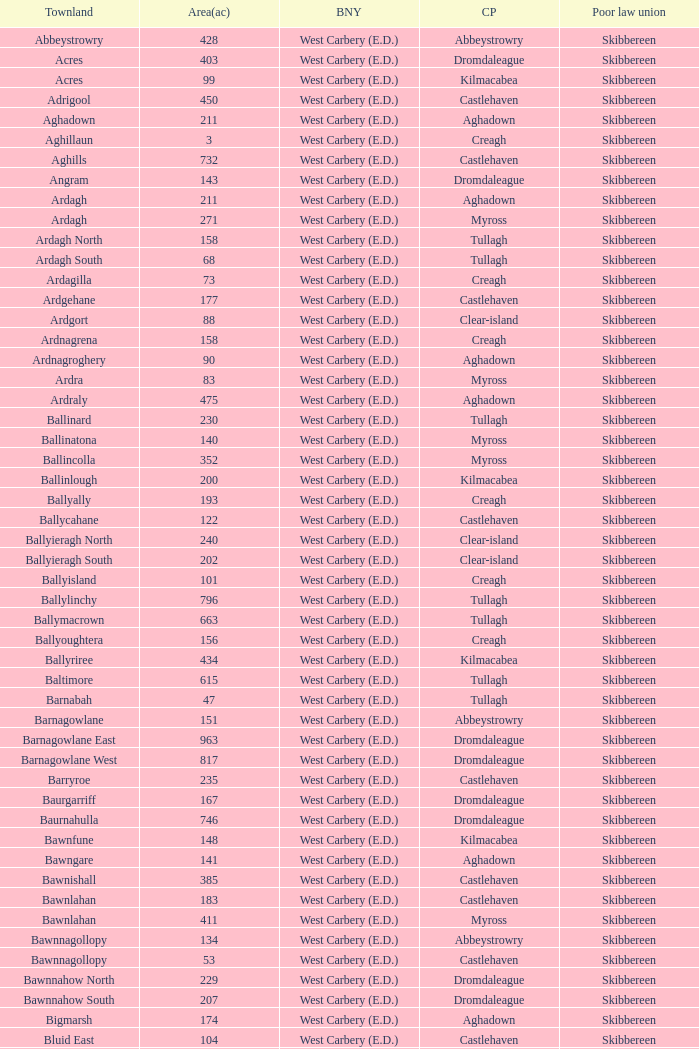What are the Poor Law Unions when the area (in acres) is 142? Skibbereen. 